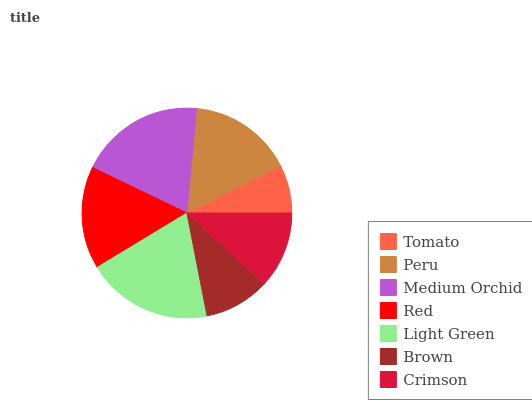Is Tomato the minimum?
Answer yes or no. Yes. Is Light Green the maximum?
Answer yes or no. Yes. Is Peru the minimum?
Answer yes or no. No. Is Peru the maximum?
Answer yes or no. No. Is Peru greater than Tomato?
Answer yes or no. Yes. Is Tomato less than Peru?
Answer yes or no. Yes. Is Tomato greater than Peru?
Answer yes or no. No. Is Peru less than Tomato?
Answer yes or no. No. Is Red the high median?
Answer yes or no. Yes. Is Red the low median?
Answer yes or no. Yes. Is Tomato the high median?
Answer yes or no. No. Is Light Green the low median?
Answer yes or no. No. 